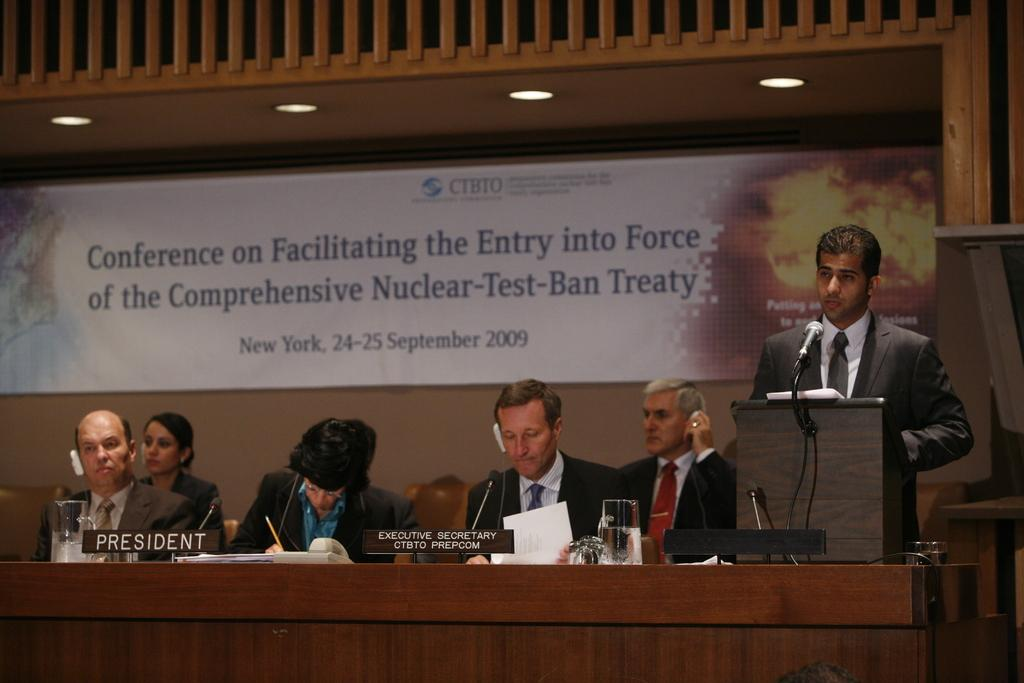What are the people in the image doing? The people in the image are sitting in front of a table. What is the person in front of the microphone doing? The person is standing and talking in front of a microphone. What can be found on the table in the image? There are objects placed on the table. Can you see a cactus growing on the table in the image? No, there is no cactus present on the table in the image. 